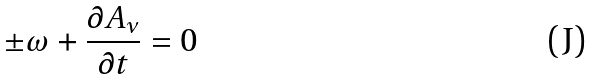<formula> <loc_0><loc_0><loc_500><loc_500>\pm \omega + \frac { \partial A _ { \nu } } { \partial t } = 0</formula> 